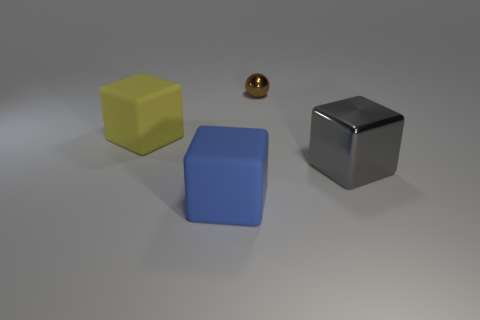Are there any other things that have the same size as the brown metallic ball?
Provide a short and direct response. No. What number of things are rubber balls or gray objects?
Keep it short and to the point. 1. Are there more big metal cubes than tiny matte blocks?
Give a very brief answer. Yes. There is a thing behind the cube to the left of the large blue matte thing; what is its size?
Make the answer very short. Small. There is another big rubber thing that is the same shape as the yellow rubber object; what color is it?
Ensure brevity in your answer.  Blue. What is the size of the yellow matte thing?
Offer a terse response. Large. What number of cubes are big yellow things or small yellow objects?
Keep it short and to the point. 1. What size is the yellow matte thing that is the same shape as the big metal thing?
Your answer should be very brief. Large. What number of big blue matte blocks are there?
Provide a short and direct response. 1. Do the tiny brown object and the metal thing to the right of the small thing have the same shape?
Give a very brief answer. No. 